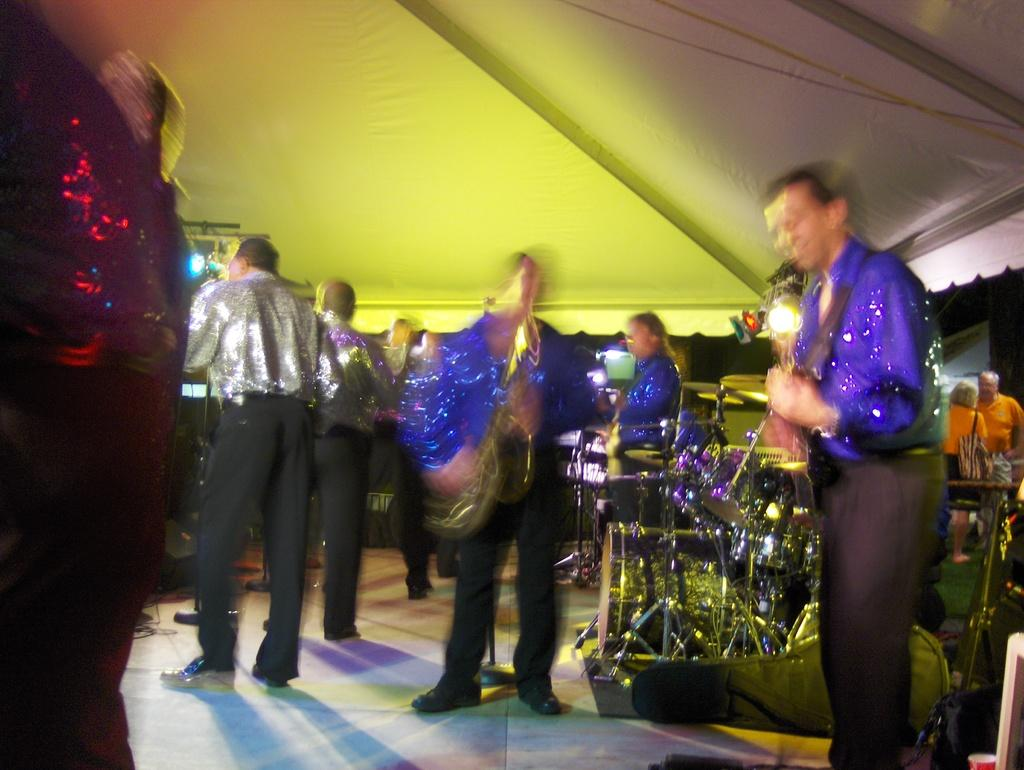What are the people in the image doing? The people in the image are standing. What else can be seen in the image besides the people? There are musical instruments and a shed visible in the image. Are there any special lighting features in the image? Yes, LED lights are present in the image. What type of comfort does the son provide in the image? There is no son present in the image, so it is not possible to answer that question. 